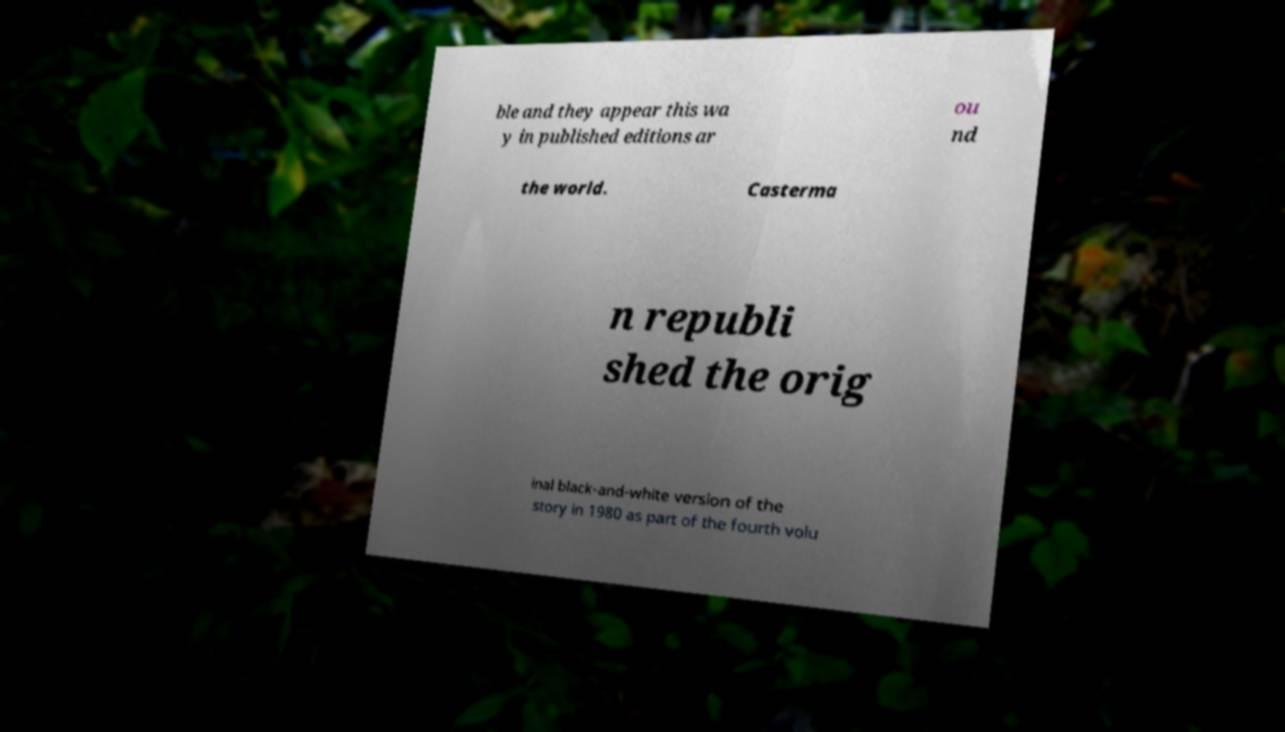Can you accurately transcribe the text from the provided image for me? ble and they appear this wa y in published editions ar ou nd the world. Casterma n republi shed the orig inal black-and-white version of the story in 1980 as part of the fourth volu 